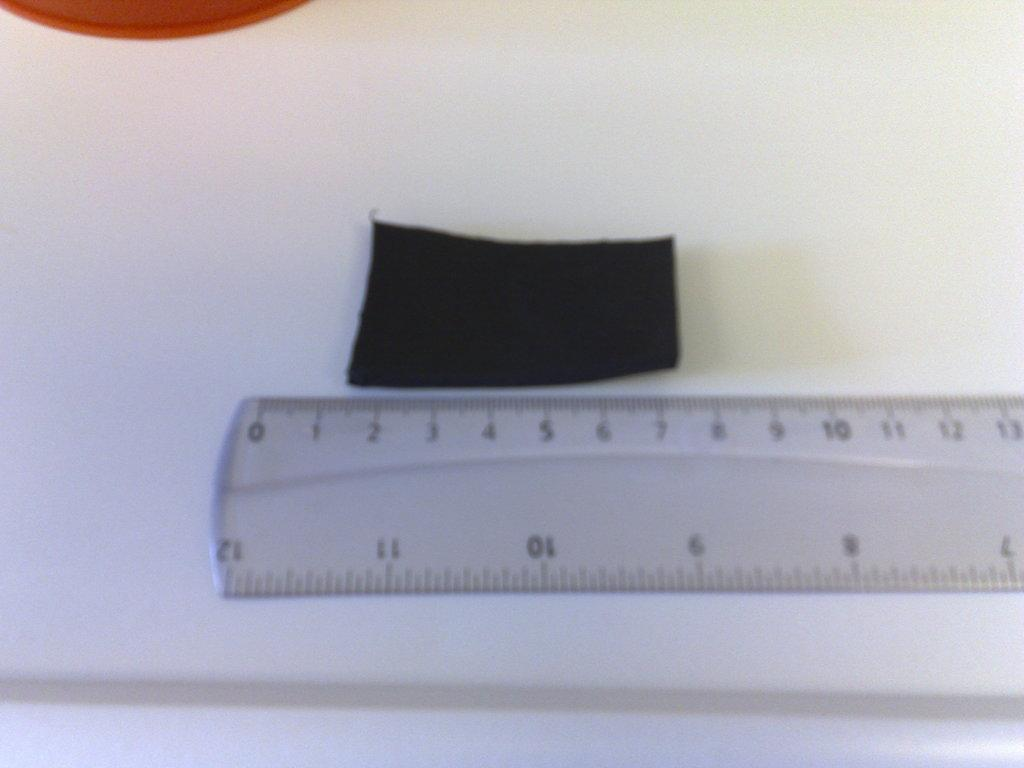<image>
Provide a brief description of the given image. A piece of black fabric sits between 1 and 8 centimeters on a ruler. 